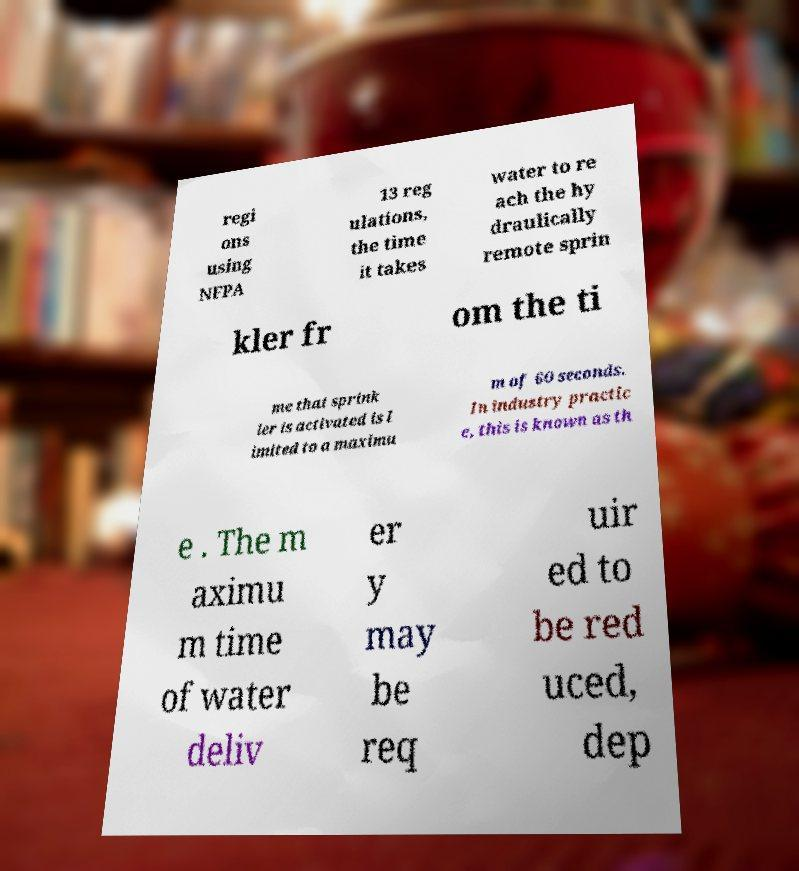I need the written content from this picture converted into text. Can you do that? regi ons using NFPA 13 reg ulations, the time it takes water to re ach the hy draulically remote sprin kler fr om the ti me that sprink ler is activated is l imited to a maximu m of 60 seconds. In industry practic e, this is known as th e . The m aximu m time of water deliv er y may be req uir ed to be red uced, dep 